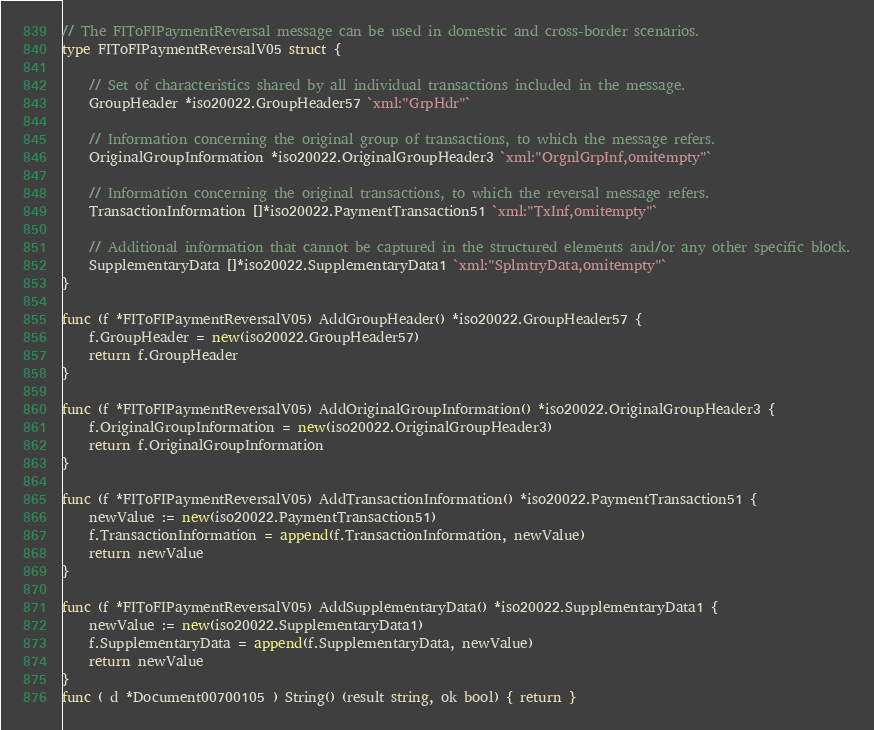Convert code to text. <code><loc_0><loc_0><loc_500><loc_500><_Go_>// The FIToFIPaymentReversal message can be used in domestic and cross-border scenarios.
type FIToFIPaymentReversalV05 struct {

	// Set of characteristics shared by all individual transactions included in the message.
	GroupHeader *iso20022.GroupHeader57 `xml:"GrpHdr"`

	// Information concerning the original group of transactions, to which the message refers.
	OriginalGroupInformation *iso20022.OriginalGroupHeader3 `xml:"OrgnlGrpInf,omitempty"`

	// Information concerning the original transactions, to which the reversal message refers.
	TransactionInformation []*iso20022.PaymentTransaction51 `xml:"TxInf,omitempty"`

	// Additional information that cannot be captured in the structured elements and/or any other specific block.
	SupplementaryData []*iso20022.SupplementaryData1 `xml:"SplmtryData,omitempty"`
}

func (f *FIToFIPaymentReversalV05) AddGroupHeader() *iso20022.GroupHeader57 {
	f.GroupHeader = new(iso20022.GroupHeader57)
	return f.GroupHeader
}

func (f *FIToFIPaymentReversalV05) AddOriginalGroupInformation() *iso20022.OriginalGroupHeader3 {
	f.OriginalGroupInformation = new(iso20022.OriginalGroupHeader3)
	return f.OriginalGroupInformation
}

func (f *FIToFIPaymentReversalV05) AddTransactionInformation() *iso20022.PaymentTransaction51 {
	newValue := new(iso20022.PaymentTransaction51)
	f.TransactionInformation = append(f.TransactionInformation, newValue)
	return newValue
}

func (f *FIToFIPaymentReversalV05) AddSupplementaryData() *iso20022.SupplementaryData1 {
	newValue := new(iso20022.SupplementaryData1)
	f.SupplementaryData = append(f.SupplementaryData, newValue)
	return newValue
}
func ( d *Document00700105 ) String() (result string, ok bool) { return }
</code> 